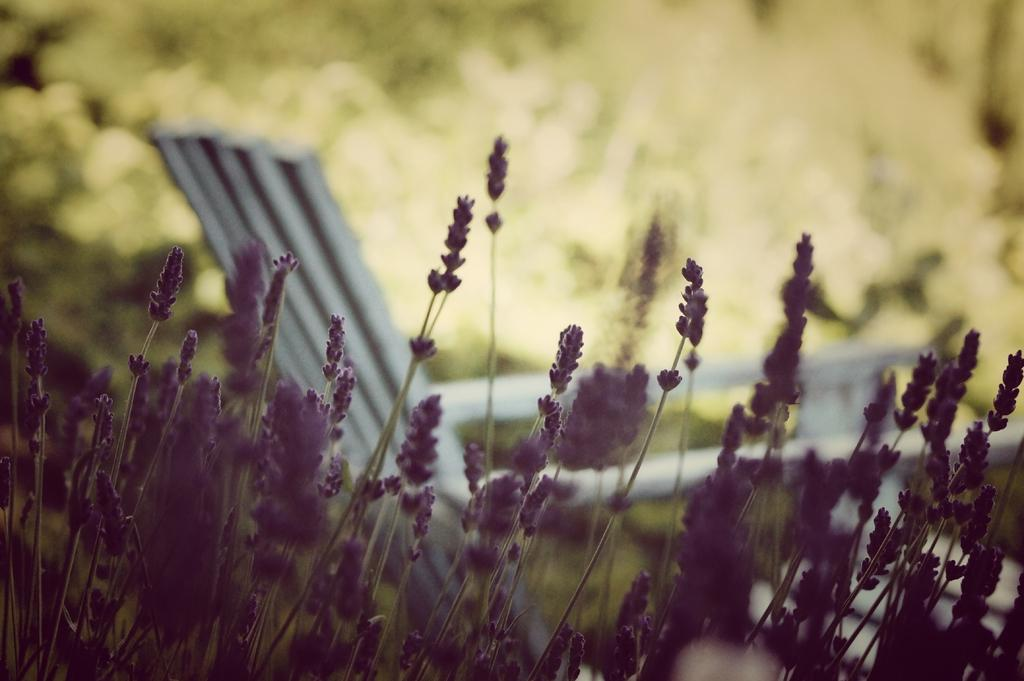What color are the flowers in the image? The flowers in the image are purple. What are the flowers growing on? The flowers are on plants. What type of seating is visible in the image? There is a white color bench in the image. Can you describe the background of the image? The background of the image is blurred. What is the reason for the wheel not being present in the image? There is no wheel mentioned or visible in the image, so it's not possible to determine a reason for its absence. 